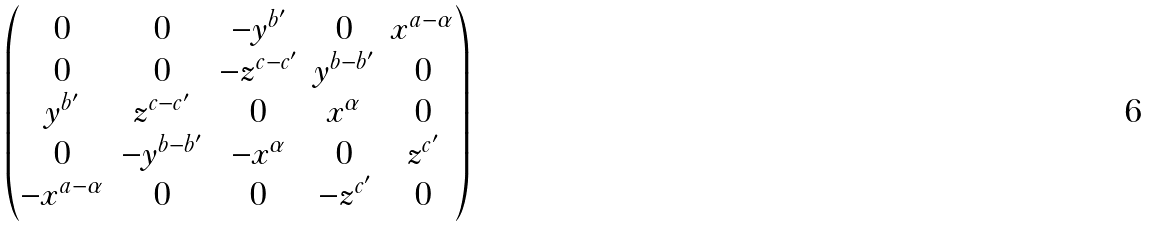Convert formula to latex. <formula><loc_0><loc_0><loc_500><loc_500>\begin{pmatrix} 0 & 0 & - y ^ { b ^ { \prime } } & 0 & x ^ { a - \alpha } \\ 0 & 0 & - z ^ { c - c ^ { \prime } } & y ^ { b - b ^ { \prime } } & 0 \\ y ^ { b ^ { \prime } } & z ^ { c - c ^ { \prime } } & 0 & x ^ { \alpha } & 0 \\ 0 & - y ^ { b - b ^ { \prime } } & - x ^ { \alpha } & 0 & z ^ { c ^ { \prime } } \\ - x ^ { a - \alpha } & 0 & 0 & - z ^ { c ^ { \prime } } & 0 \end{pmatrix}</formula> 